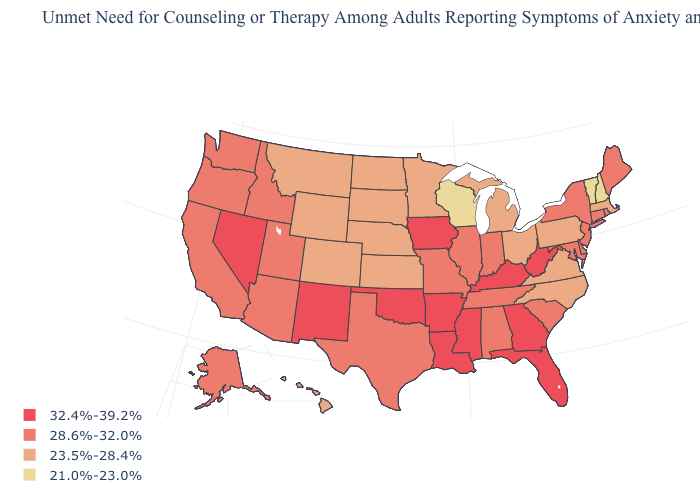What is the lowest value in states that border Massachusetts?
Concise answer only. 21.0%-23.0%. What is the value of Wisconsin?
Keep it brief. 21.0%-23.0%. Name the states that have a value in the range 21.0%-23.0%?
Write a very short answer. New Hampshire, Vermont, Wisconsin. Among the states that border Kentucky , which have the lowest value?
Short answer required. Ohio, Virginia. Among the states that border Kentucky , does West Virginia have the highest value?
Write a very short answer. Yes. What is the highest value in the MidWest ?
Write a very short answer. 32.4%-39.2%. What is the highest value in the South ?
Give a very brief answer. 32.4%-39.2%. What is the lowest value in the USA?
Concise answer only. 21.0%-23.0%. What is the lowest value in the USA?
Short answer required. 21.0%-23.0%. What is the value of Montana?
Answer briefly. 23.5%-28.4%. Which states have the lowest value in the West?
Concise answer only. Colorado, Hawaii, Montana, Wyoming. What is the lowest value in the USA?
Concise answer only. 21.0%-23.0%. What is the highest value in the West ?
Be succinct. 32.4%-39.2%. What is the value of Vermont?
Write a very short answer. 21.0%-23.0%. Among the states that border Georgia , does Florida have the highest value?
Short answer required. Yes. 